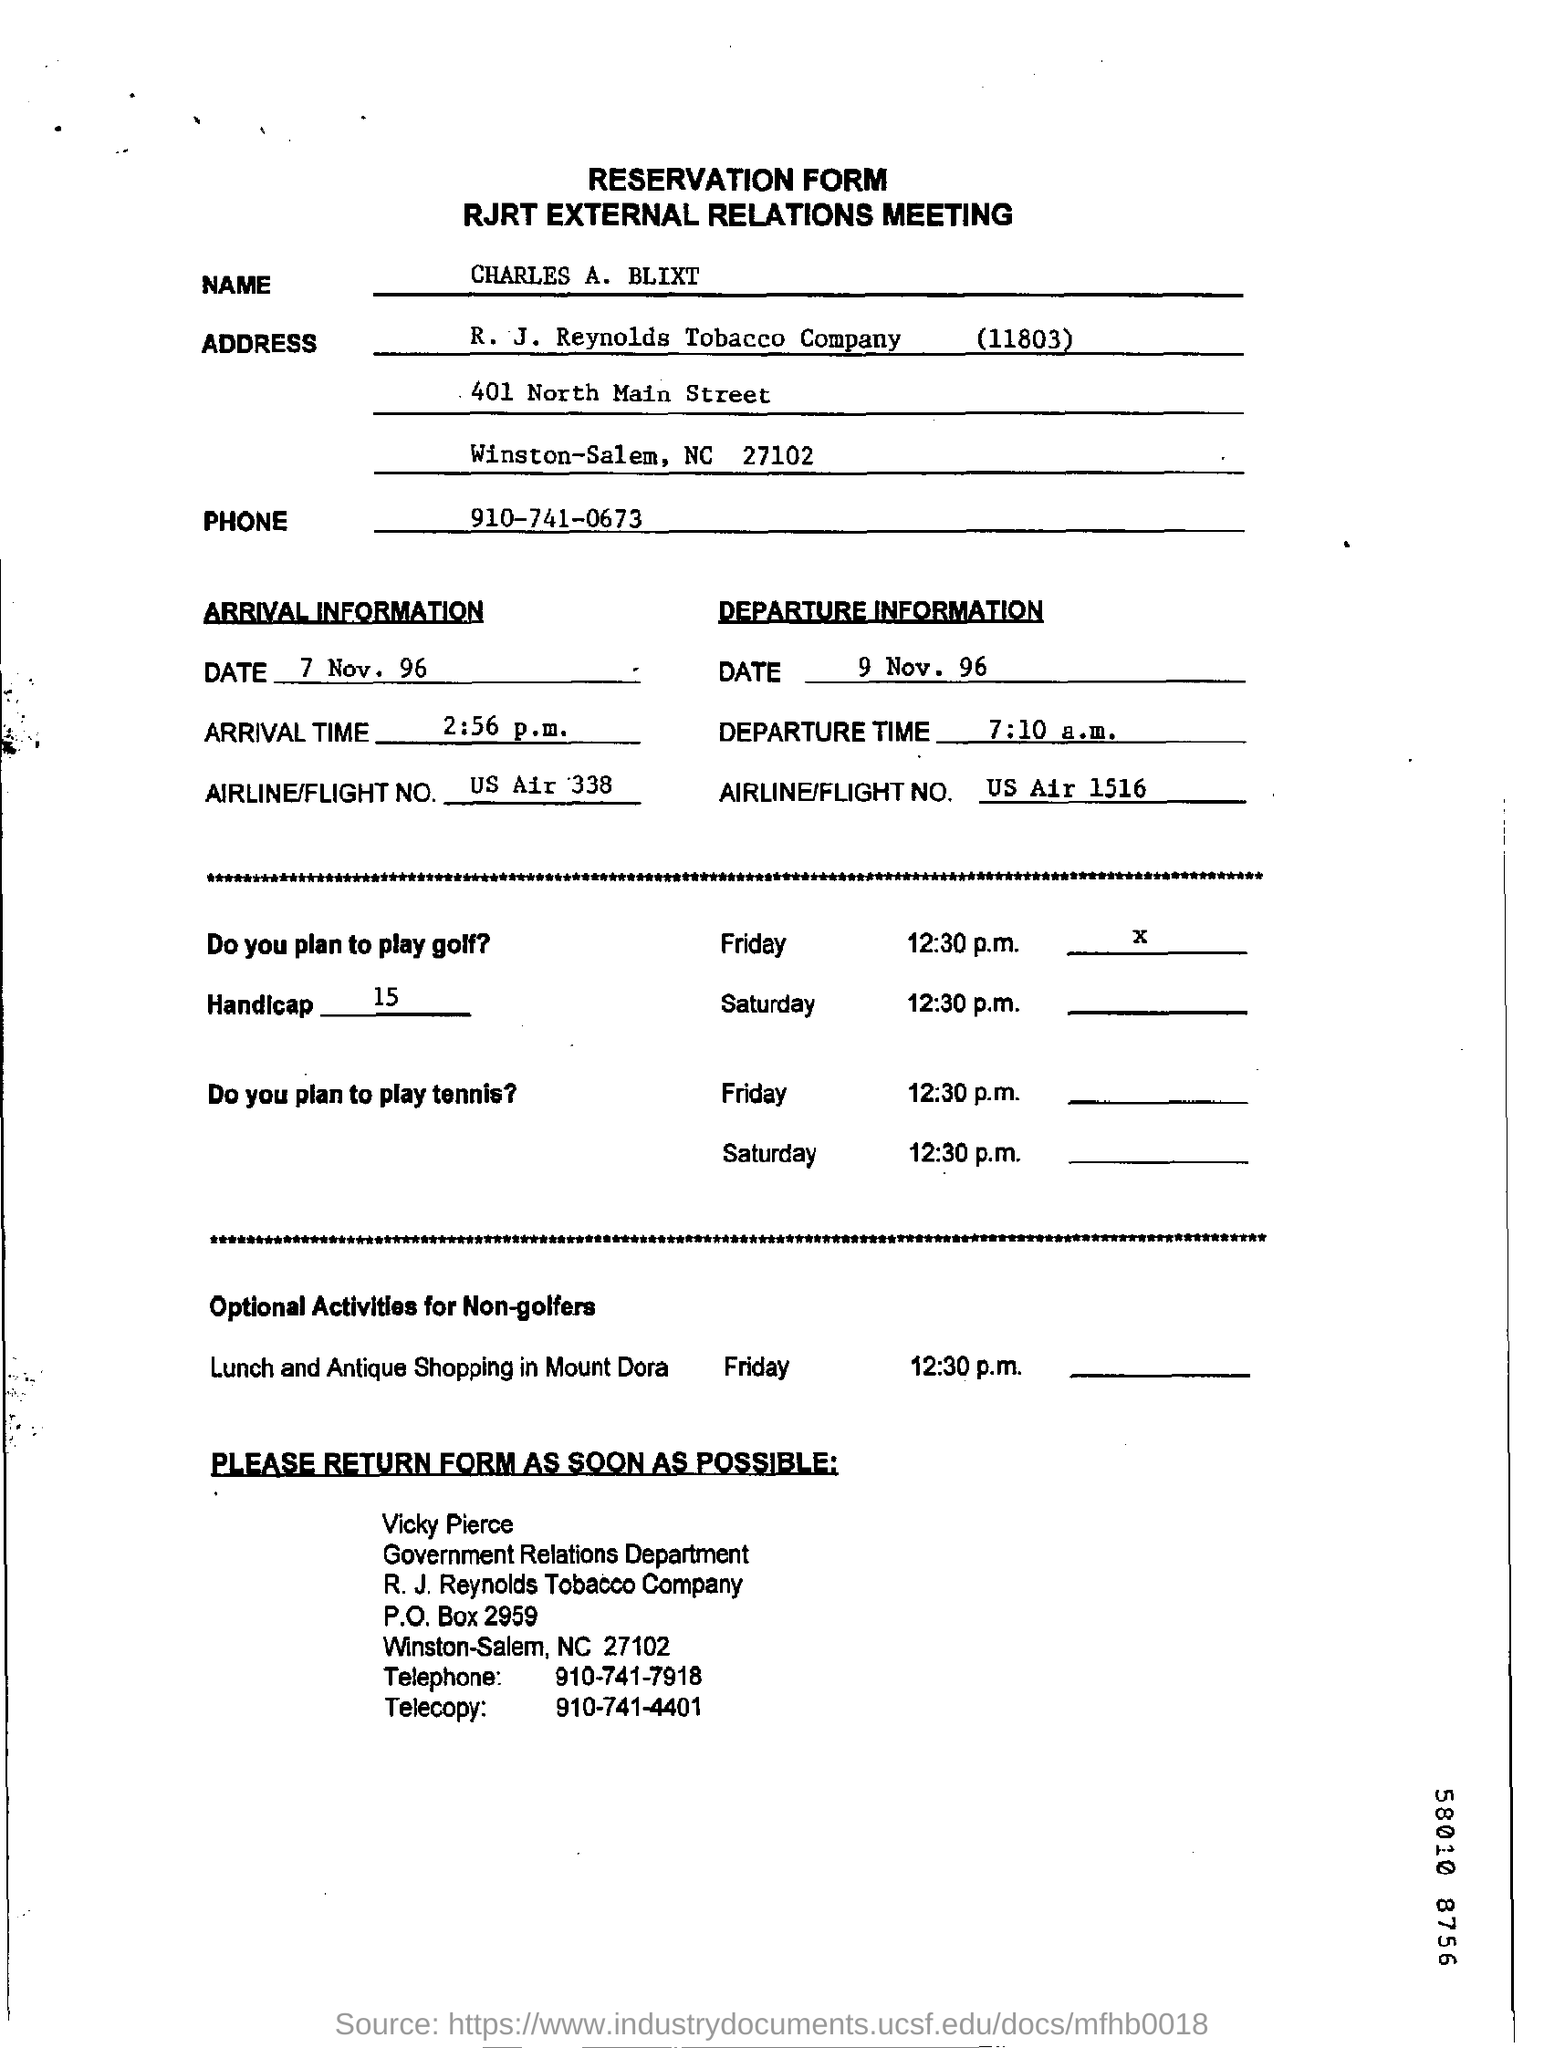What is the Name?
Provide a succinct answer. Charles A. Blixt. What is the Phone?
Your response must be concise. 910-741-0673. What is the Date of Arrival?
Your answer should be very brief. 7 Nov. 96. What is the Date of Departure?
Provide a succinct answer. 9 nov. 96. What is the Arrival Time?
Ensure brevity in your answer.  2:56 p.m. What is the Departure Time?
Your answer should be compact. 7:10 a.m. 